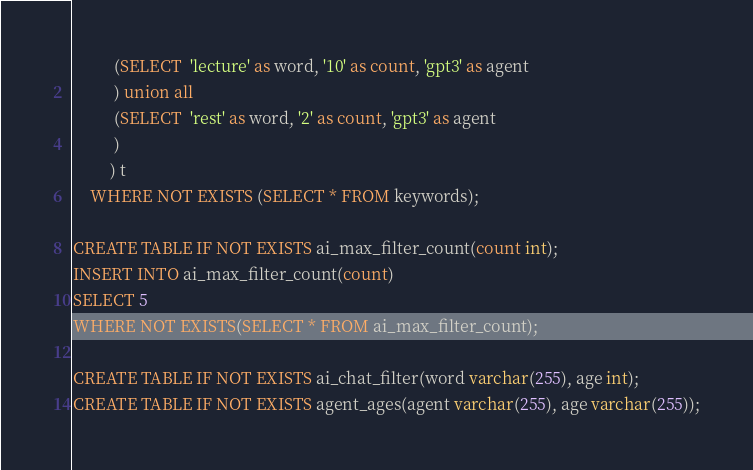<code> <loc_0><loc_0><loc_500><loc_500><_SQL_>          (SELECT  'lecture' as word, '10' as count, 'gpt3' as agent
          ) union all
          (SELECT  'rest' as word, '2' as count, 'gpt3' as agent
          )
         ) t
    WHERE NOT EXISTS (SELECT * FROM keywords);

CREATE TABLE IF NOT EXISTS ai_max_filter_count(count int);
INSERT INTO ai_max_filter_count(count)
SELECT 5
WHERE NOT EXISTS(SELECT * FROM ai_max_filter_count);

CREATE TABLE IF NOT EXISTS ai_chat_filter(word varchar(255), age int);
CREATE TABLE IF NOT EXISTS agent_ages(agent varchar(255), age varchar(255));</code> 